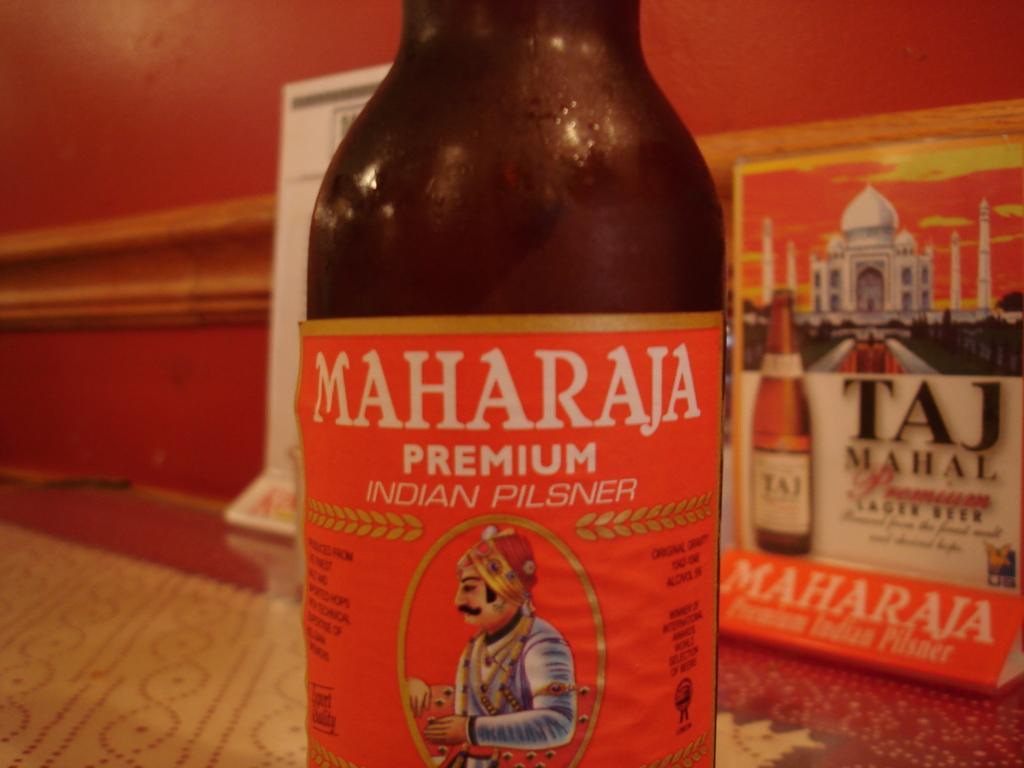How would you summarize this image in a sentence or two? In this image I can see a bottle which is black in color and a red and white colored sticker attached to the bottle. In the background I can see the red colored wall and two boards which are white and orange in color. 